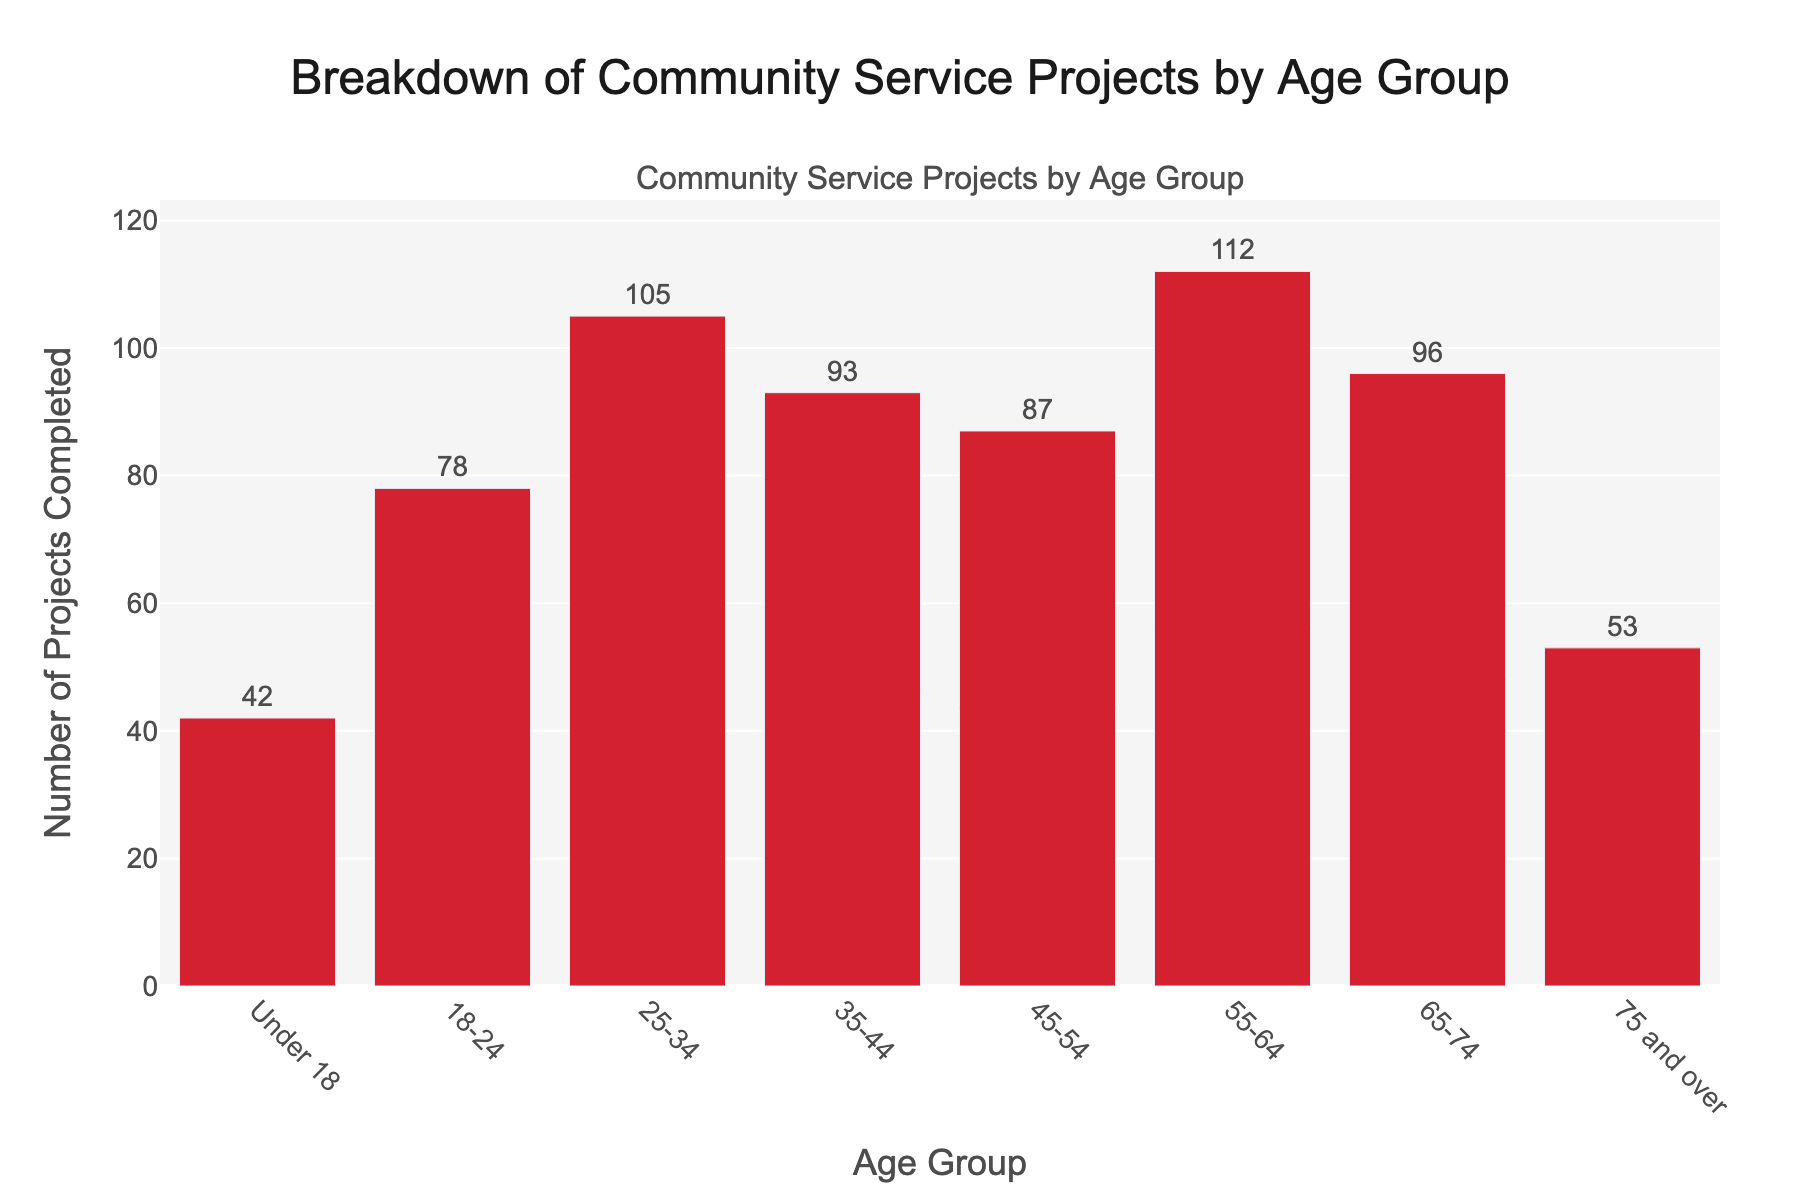Which age group completed the most projects? To find the answer, look for the longest bar in the chart. The bar for the 55-64 age group is the longest, indicating they completed the most projects.
Answer: 55-64 How many more projects did the 55-64 age group complete compared to the 75 and over age group? The 55-64 age group completed 112 projects, while the 75 and over age group completed 53. Subtract 53 from 112 to find the difference (112 - 53 = 59).
Answer: 59 Which age groups completed fewer projects than the 35-44 age group? The 35-44 age group completed 93 projects. Compare this value with the number of projects completed by each age group. The groups under 18, 18-24, 45-54, 65-74, and 75 and over completed fewer projects.
Answer: Under 18, 18-24, 45-54, 75 and over What is the total number of projects completed by volunteers in the 25-34 and 35-44 age groups? Add the projects completed by the 25-34 age group (105) and the 35-44 age group (93). The sum is 105 + 93 = 198.
Answer: 198 Which age group has nearly the same number of completed projects as the 35-44 age group? The 35-44 age group completed 93 projects. The 65-74 age group's number of projects is closest to this value with 96 projects, which is just 3 more.
Answer: 65-74 Is the number of projects completed by the 18-24 age group greater than that of the 45-54 age group? The 18-24 age group completed 78 projects, while the 45-54 age group completed 87 projects. Compare these numbers; 78 is less than 87.
Answer: No What is the combined total of projects completed by the youngest (under 18) and oldest (75 and over) age groups? Add the projects completed by the under-18 age group (42) and the 75 and over age group (53). The sum is 42 + 53 = 95.
Answer: 95 Which age group has the third-highest number of completed projects? First, identify the highest (55-64), second highest (25-34), and third highest (65-74) number of projects by comparing the lengths of the bars.
Answer: 65-74 How many more projects did the 25-34 age group complete compared to the 18-24 age group? The 25-34 age group completed 105 projects, while the 18-24 age group completed 78. Subtract 78 from 105 to find the difference (105 - 78 = 27).
Answer: 27 How many projects were completed in total by all age groups combined? Sum the projects completed by each age group: 42 + 78 + 105 + 93 + 87 + 112 + 96 + 53 = 666.
Answer: 666 